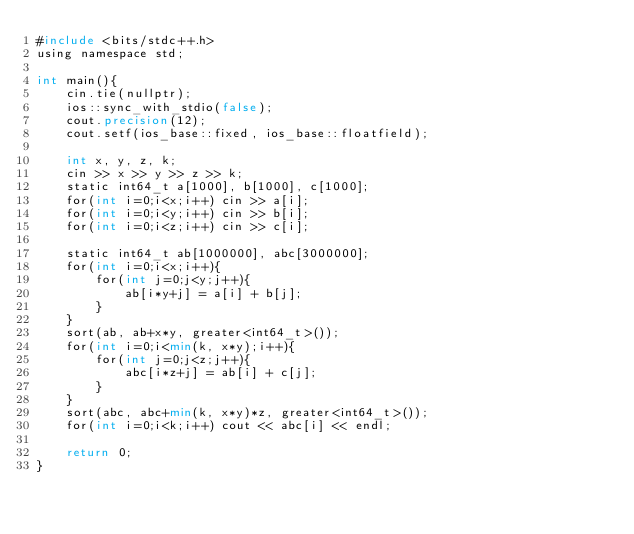<code> <loc_0><loc_0><loc_500><loc_500><_FORTRAN_>#include <bits/stdc++.h>
using namespace std;

int main(){
    cin.tie(nullptr);
    ios::sync_with_stdio(false);
    cout.precision(12);
    cout.setf(ios_base::fixed, ios_base::floatfield);
    
    int x, y, z, k;
    cin >> x >> y >> z >> k;
    static int64_t a[1000], b[1000], c[1000];
    for(int i=0;i<x;i++) cin >> a[i];
    for(int i=0;i<y;i++) cin >> b[i];
    for(int i=0;i<z;i++) cin >> c[i];
    
    static int64_t ab[1000000], abc[3000000];
    for(int i=0;i<x;i++){
        for(int j=0;j<y;j++){
            ab[i*y+j] = a[i] + b[j];
        }
    }
    sort(ab, ab+x*y, greater<int64_t>());
    for(int i=0;i<min(k, x*y);i++){
        for(int j=0;j<z;j++){
            abc[i*z+j] = ab[i] + c[j];
        }
    }
    sort(abc, abc+min(k, x*y)*z, greater<int64_t>());
    for(int i=0;i<k;i++) cout << abc[i] << endl;
    
    return 0;
}</code> 